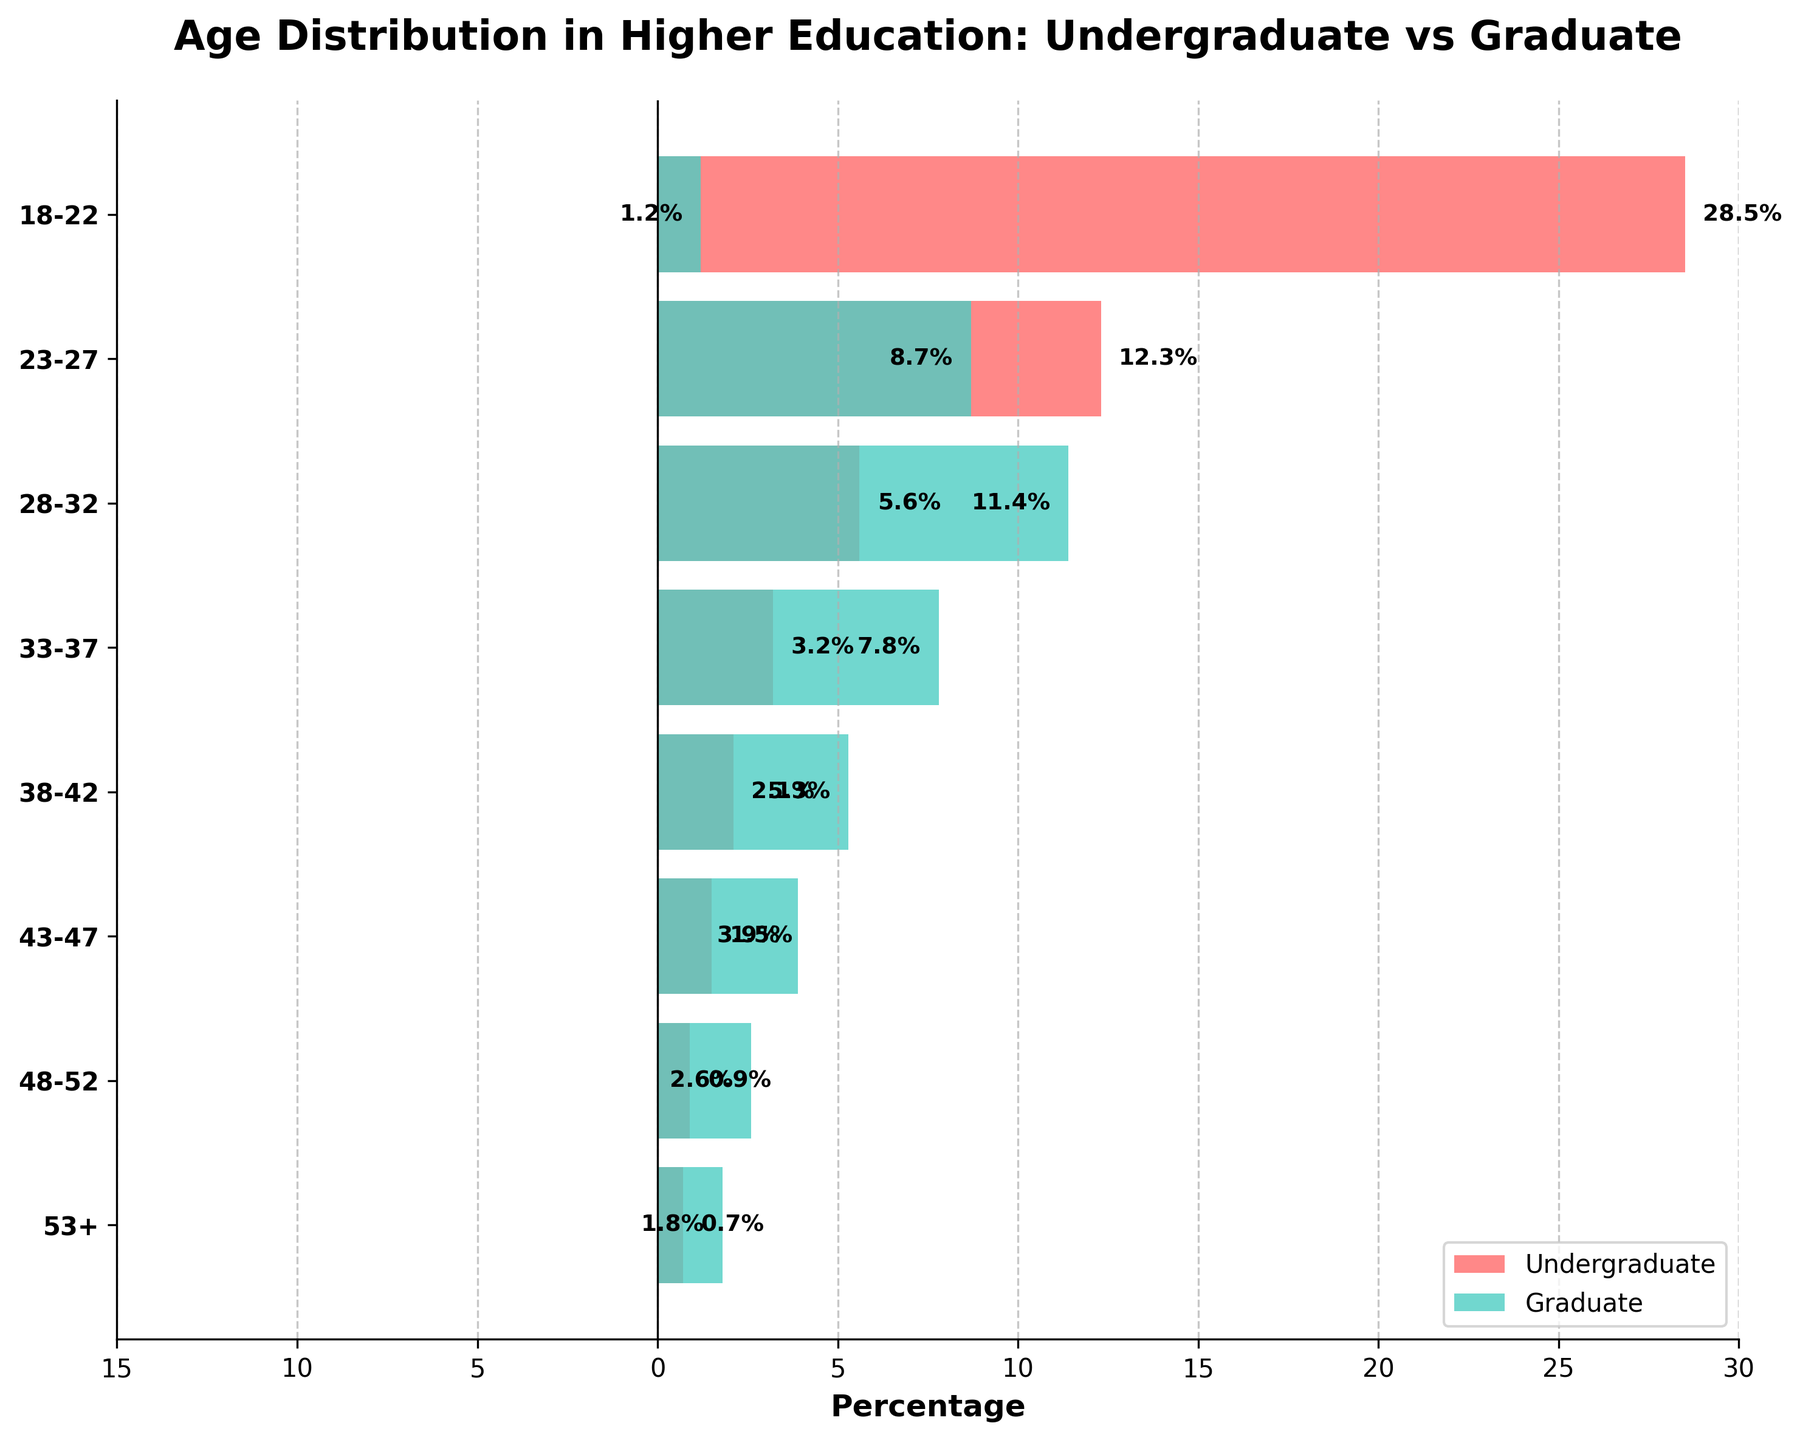What is the title of the figure? The title of the figure is displayed at the top and often summarizes the main information it conveys. In this case, you can find the summarized information in the title located above the chart.
Answer: Age Distribution in Higher Education: Undergraduate vs Graduate What is the age group with the highest percentage of undergraduate students? To find the age group with the highest percentage of undergraduate students, look at the bar lengths representing undergraduates on the right side of the pyramid. The longest bar corresponds to the highest percentage.
Answer: 18-22 In which age group do graduate students have their highest percentage? Examine the bars on the left side of the pyramid, with negative values indicating graduate percentages. Identify the age group with the longest bar on this side.
Answer: 28-32 What is the combined percentage of undergraduate and graduate students in the 23-27 age group? Refer to the 23-27 age group. Sum the given percentages for undergraduates (12.3) and the magnitude of graduates (-8.7, or 8.7).
Answer: 21.0% Which age group has a higher percentage of graduate students compared to undergraduate students? Compare the lengths of the bars on both sides for each age group. Identify the group where the left bar (graduates) surpasses the right bar (undergraduates).
Answer: 28-32 What is the difference in percentage between undergraduates and graduates in the 33-37 age group? For the 33-37 age group, subtract the percentage of graduate students (7.8) from the percentage of undergraduate students (3.2).
Answer: -4.6% Which age group has the smallest percentage of undergraduate students, and what is that percentage? Identify the smallest value among the bars on the right side of the pyramid. Check the age group associated with this bar.
Answer: 53+, 0.7% How does the percentage of students in the 43-47 age group compare between undergraduates and graduates? Look at the bars for the 43-47 age group. Check the lengths of both bars to determine which side (undergraduates or graduates) has a relatively longer bar, indicating a higher percentage.
Answer: Undergraduates have a higher percentage How does the age distribution of undergraduates differ from that of graduates across the age groups? Observe the general trend and distribution of bar lengths on both sides for undergraduates and graduates. Note the younger vs. older age grouping and relative concentrations.
Answer: Undergraduates are concentrated in younger age groups, while graduates are more evenly spread across older age groups 